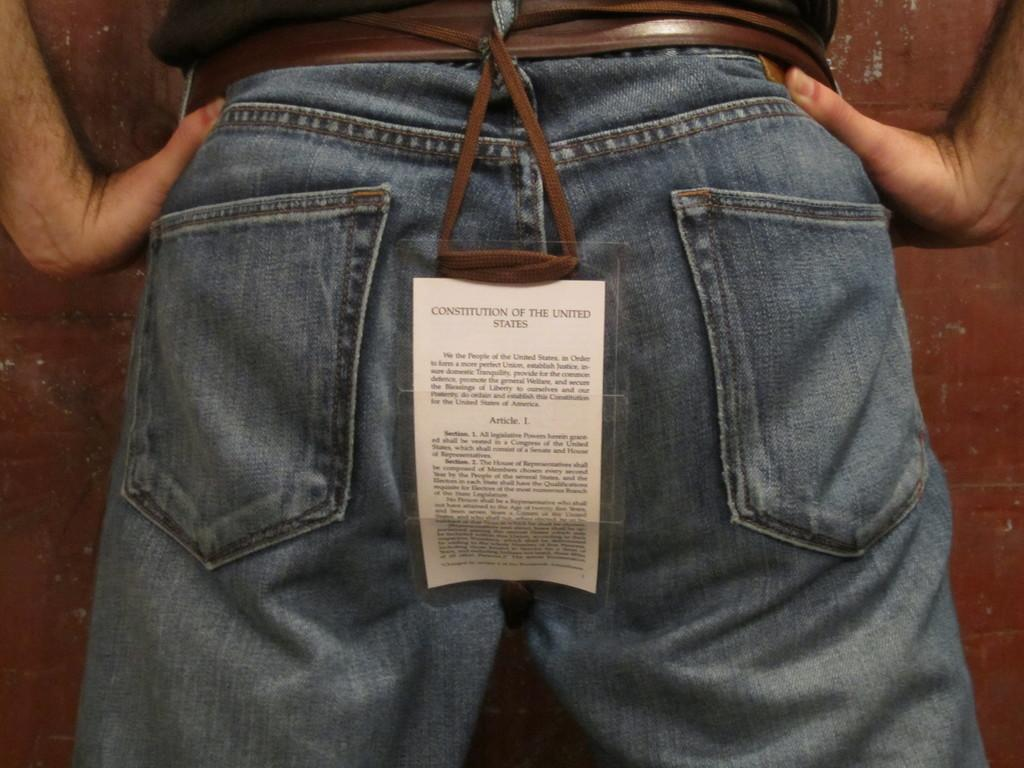What is the main object in the center of the image? There is a banner in the center of the image. Who or what is near the banner? There is a person standing near the banner. What can be read on the banner? The banner has text on it. What can be seen in the background of the image? There is a wall and other objects visible in the background. How many grandmothers are sitting on the grass in the image? There is no grass or grandmother present in the image. What are the men doing in the background of the image? There is no mention of men in the provided facts, so we cannot answer this question. 